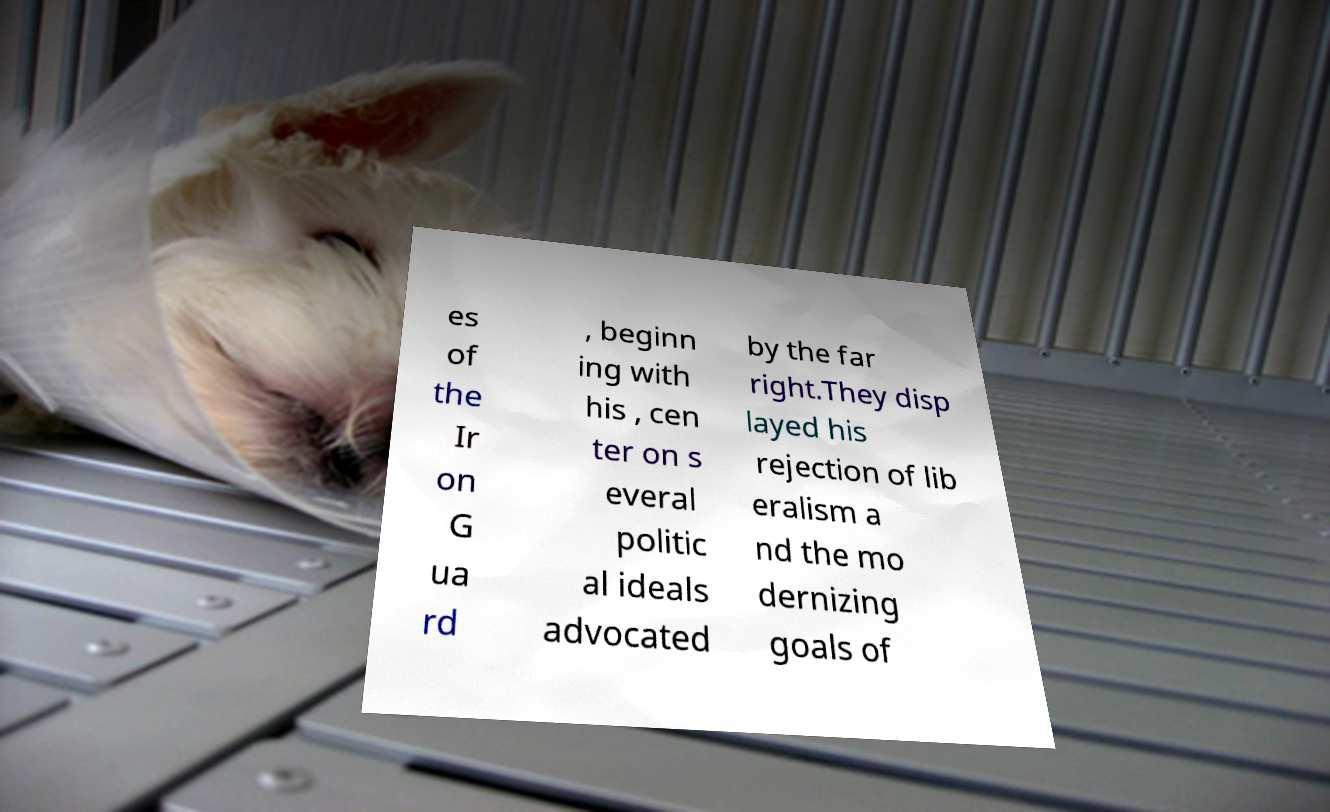Can you accurately transcribe the text from the provided image for me? es of the Ir on G ua rd , beginn ing with his , cen ter on s everal politic al ideals advocated by the far right.They disp layed his rejection of lib eralism a nd the mo dernizing goals of 